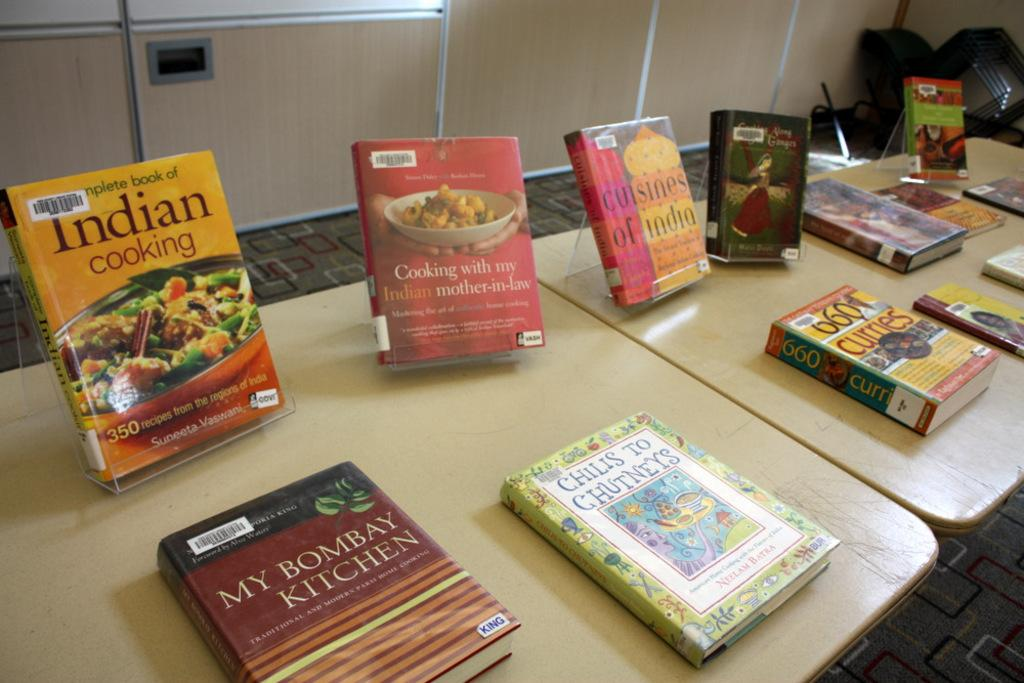<image>
Write a terse but informative summary of the picture. A book on Indian cooking is on a table with other books. 